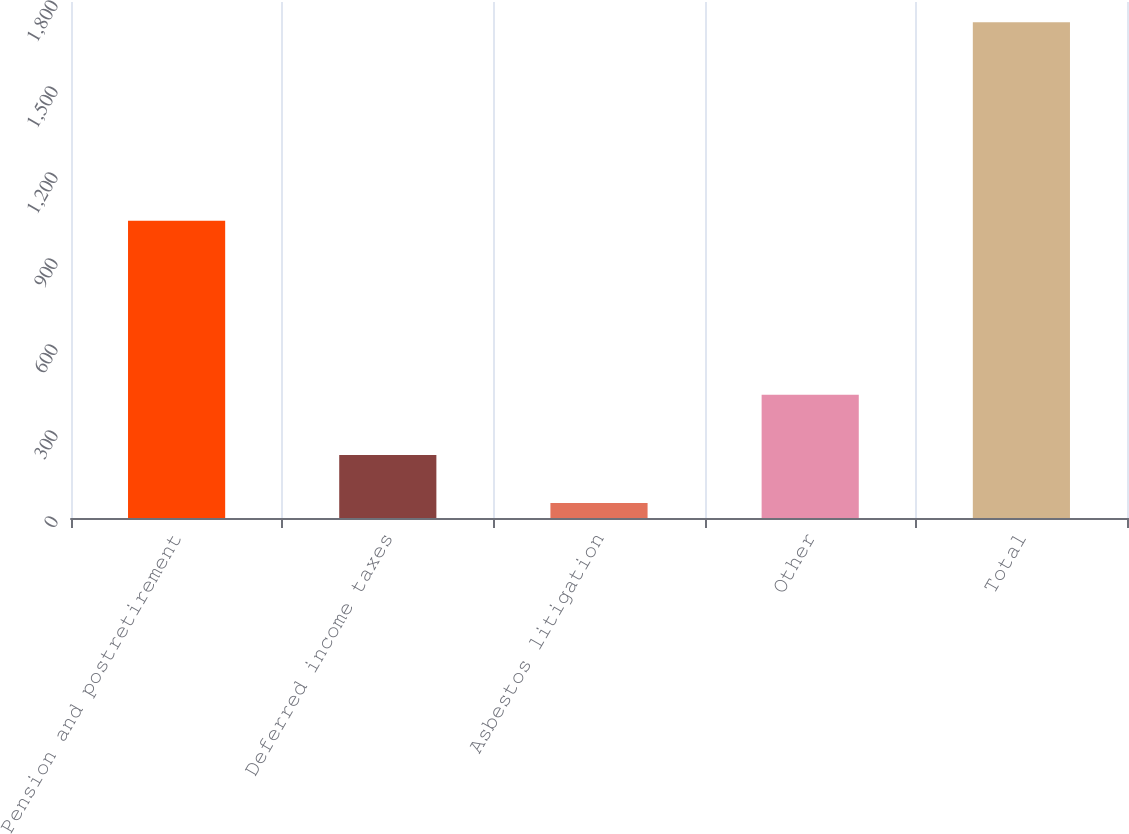Convert chart. <chart><loc_0><loc_0><loc_500><loc_500><bar_chart><fcel>Pension and postretirement<fcel>Deferred income taxes<fcel>Asbestos litigation<fcel>Other<fcel>Total<nl><fcel>1037<fcel>219.7<fcel>52<fcel>430<fcel>1729<nl></chart> 